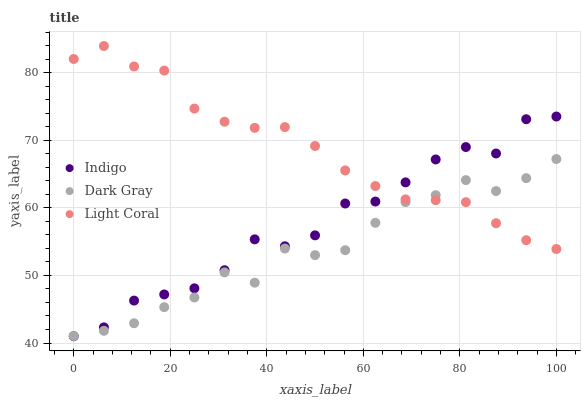Does Dark Gray have the minimum area under the curve?
Answer yes or no. Yes. Does Light Coral have the maximum area under the curve?
Answer yes or no. Yes. Does Indigo have the minimum area under the curve?
Answer yes or no. No. Does Indigo have the maximum area under the curve?
Answer yes or no. No. Is Light Coral the smoothest?
Answer yes or no. Yes. Is Indigo the roughest?
Answer yes or no. Yes. Is Indigo the smoothest?
Answer yes or no. No. Is Light Coral the roughest?
Answer yes or no. No. Does Indigo have the lowest value?
Answer yes or no. Yes. Does Light Coral have the lowest value?
Answer yes or no. No. Does Light Coral have the highest value?
Answer yes or no. Yes. Does Indigo have the highest value?
Answer yes or no. No. Does Dark Gray intersect Indigo?
Answer yes or no. Yes. Is Dark Gray less than Indigo?
Answer yes or no. No. Is Dark Gray greater than Indigo?
Answer yes or no. No. 